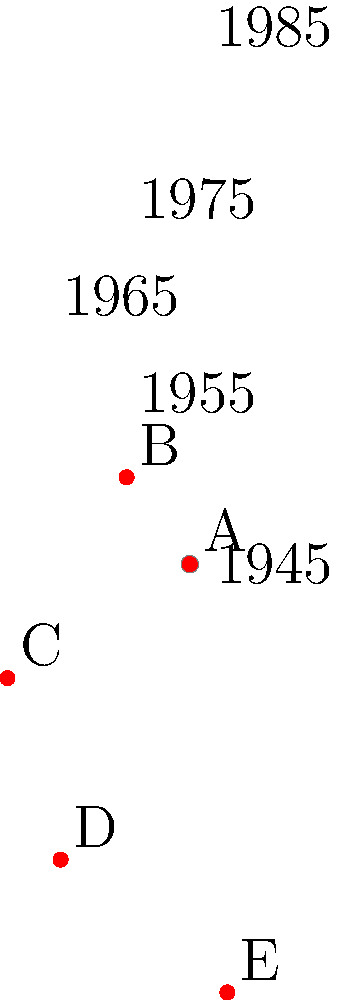On this polar coordinate grid representing major Cold War events from 1945 to 1990, each concentric circle represents a 10-year interval, and the angular position represents the year (starting from 1945 at 0°). Which event, labeled A through E, most likely represents the Cuban Missile Crisis? To answer this question, we need to analyze the position of each event on the polar grid and match it with our knowledge of Cold War chronology:

1. The center of the grid represents 1945, the end of World War II and the beginning of the Cold War.
2. Each concentric circle represents a 10-year interval, so the outermost circle is 1985.
3. The angular position represents the year, with 0° (right side) being 1945, and moving counterclockwise.

Now, let's examine each event:

A: Close to the center, around 1947-1948. This could be the Truman Doctrine or Marshall Plan.
B: About halfway to the second circle, approximately 90° from the start. This corresponds to around 1955-1956, possibly the Warsaw Pact formation or Hungarian Revolution.
C: Between the third and fourth circles, about 140° from the start. This is around 1962-1963.
D: Close to the fourth circle, about 220° from the start. This is around 1972-1973, possibly the SALT I treaty.
E: Near the outermost circle, about 290° from the start. This is around 1982-1983, possibly related to the "Evil Empire" speech or the Strategic Defense Initiative.

The Cuban Missile Crisis occurred in October 1962, which aligns best with the position of event C on the grid.
Answer: C 